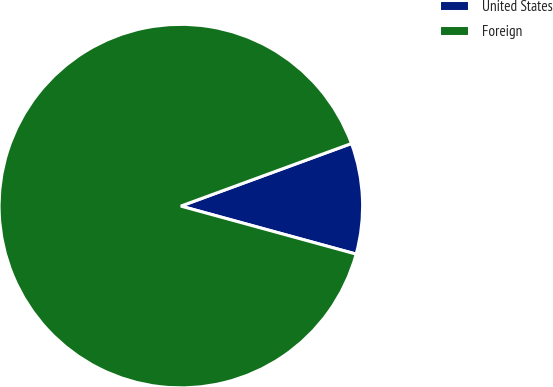Convert chart. <chart><loc_0><loc_0><loc_500><loc_500><pie_chart><fcel>United States<fcel>Foreign<nl><fcel>9.85%<fcel>90.15%<nl></chart> 